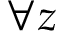<formula> <loc_0><loc_0><loc_500><loc_500>\forall z</formula> 